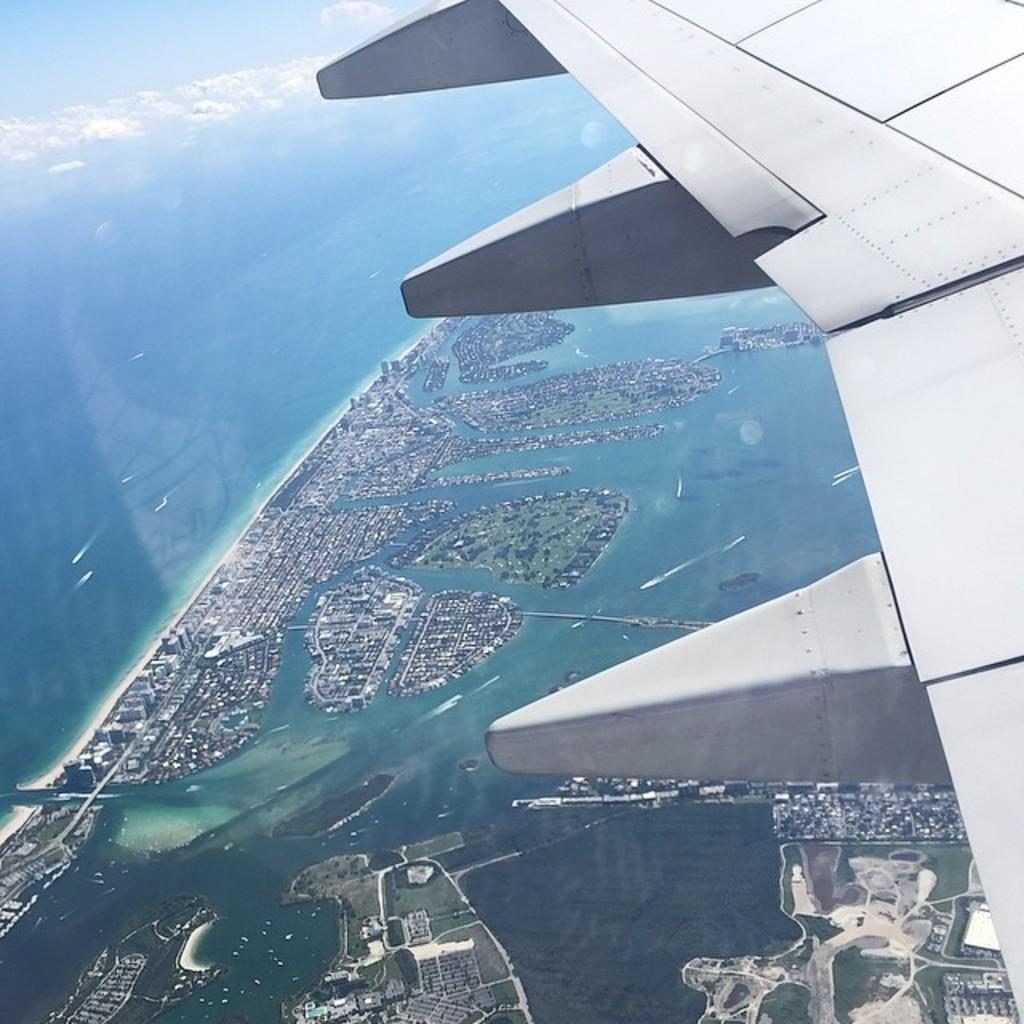What is the main subject of the image? The main subject of the image is the wing of an aircraft. What is the color of the wing? The wing is white in color. What can be seen in the background of the image? In the background, there is water, the sky, buildings, trees, and boats visible. How many crates are stacked on top of the wing in the image? There are no crates present in the image; it only shows the wing of an aircraft. What type of birds can be seen flying near the wing in the image? There are no birds visible in the image; it only shows the wing of an aircraft and the background elements. 